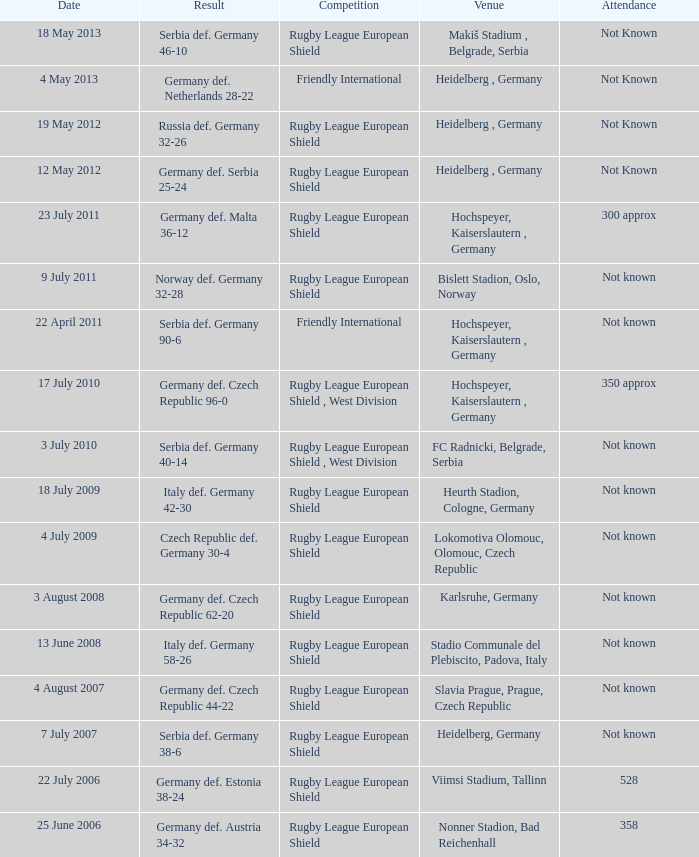For the game with 528 attendance, what was the result? Germany def. Estonia 38-24. 